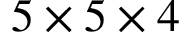Convert formula to latex. <formula><loc_0><loc_0><loc_500><loc_500>5 \times 5 \times 4</formula> 